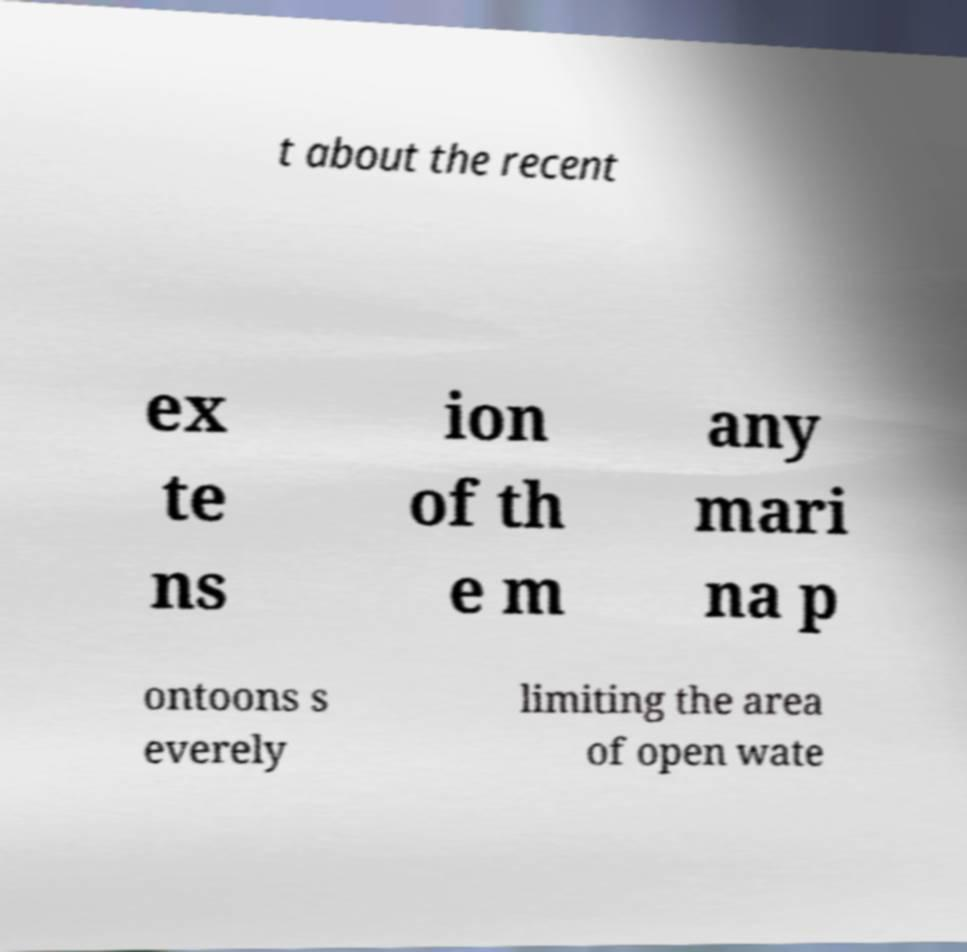Can you read and provide the text displayed in the image?This photo seems to have some interesting text. Can you extract and type it out for me? t about the recent ex te ns ion of th e m any mari na p ontoons s everely limiting the area of open wate 